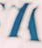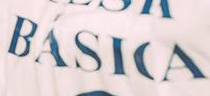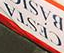What text appears in these images from left to right, separated by a semicolon? #; BÁSICA; CESTA 